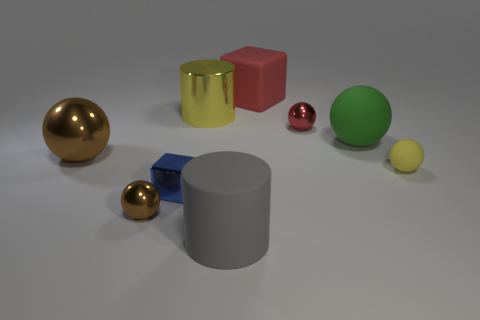Is there another small metal object of the same shape as the tiny red shiny object?
Offer a terse response. Yes. Are there fewer tiny red shiny things that are to the left of the tiny red shiny object than tiny rubber balls?
Provide a succinct answer. Yes. Is the yellow metal thing the same shape as the red shiny thing?
Keep it short and to the point. No. There is a brown shiny sphere that is behind the small brown shiny thing; what is its size?
Your answer should be compact. Large. What is the size of the gray object that is the same material as the green sphere?
Offer a terse response. Large. Are there fewer small red spheres than large shiny objects?
Keep it short and to the point. Yes. There is a red thing that is the same size as the yellow metallic cylinder; what is its material?
Make the answer very short. Rubber. Are there more small shiny cylinders than blue blocks?
Offer a very short reply. No. What number of other things are there of the same color as the large matte ball?
Give a very brief answer. 0. How many big things are both behind the tiny yellow sphere and to the left of the big red rubber thing?
Your response must be concise. 2. 